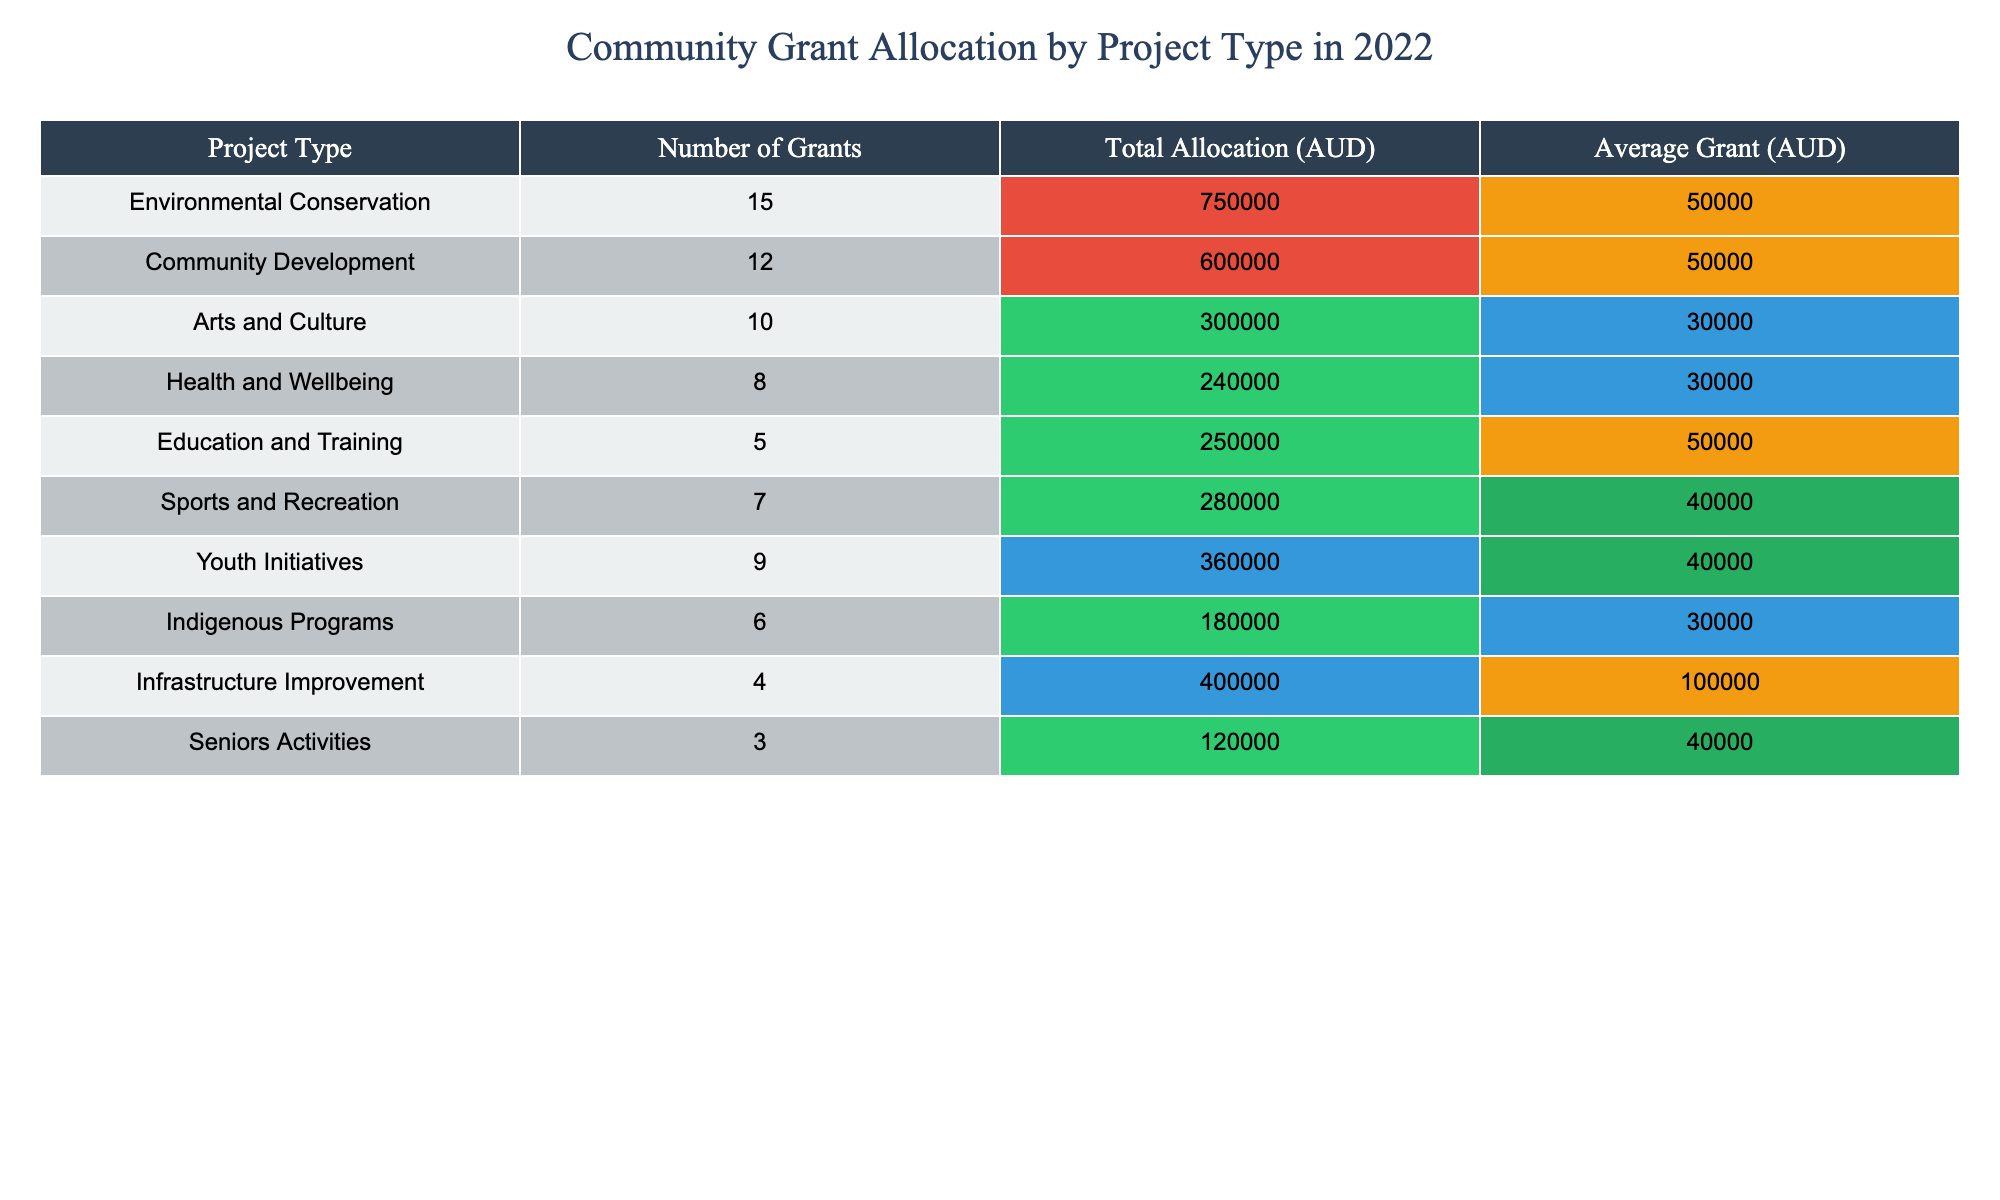What project type received the highest total allocation in 2022? The project type with the highest total allocation can be found by looking for the maximum value in the "Total Allocation (AUD)" column. The highest value is 750000, which corresponds to "Environmental Conservation."
Answer: Environmental Conservation How many grants were awarded for Community Development? The number of grants for "Community Development" is directly listed in the table under the "Number of Grants" column. It is 12.
Answer: 12 What is the average grant amount for Sports and Recreation? The average grant amount for "Sports and Recreation" can be found in the "Average Grant (AUD)" column. It is 40000.
Answer: 40000 Which project type had the fewest number of grants awarded? To determine which project had the fewest grants, we compare the values in the "Number of Grants" column. The minimum value is 3, associated with "Seniors Activities."
Answer: Seniors Activities What is the total allocation for Youth Initiatives and Health and Wellbeing combined? The total allocation for "Youth Initiatives" is 360000 and for "Health and Wellbeing" is 240000. Adding these gives 360000 + 240000 = 600000.
Answer: 600000 Is the average grant amount for Education and Training greater than that for Arts and Culture? The average grant for "Education and Training" is 50000 and for "Arts and Culture" it is 30000. Since 50000 is greater than 30000, the statement is true.
Answer: Yes What is the total allocation for all projects with an average grant of at least 40000? The project types with an average grant of at least 40000 are "Environmental Conservation," "Community Development," "Sports and Recreation," and "Youth Initiatives." Their allocations are 750000, 600000, 280000, and 360000 respectively. Adding these gives 750000 + 600000 + 280000 + 360000 = 1990000.
Answer: 1990000 How many more projects received grants in the Environmental Conservation category compared to Indigenous Programs? "Environmental Conservation" had 15 grants and "Indigenous Programs" had 6 grants. The difference is 15 - 6 = 9.
Answer: 9 How many project types received more than 400000 AUD in total allocation? The project types with more than 400000 AUD in total allocation are "Environmental Conservation" (750000), "Community Development" (600000), and "Infrastructure Improvement" (400000). This gives three project types.
Answer: 3 What percentage of the total allocation was given to Arts and Culture? The total allocation across all projects can be calculated by summing the "Total Allocation (AUD)" column. The allocation for "Arts and Culture" is 300000. The total allocation is 750000 + 600000 + 300000 + 240000 + 250000 + 280000 + 360000 + 180000 + 400000 + 120000 = 2880000. The percentage is (300000 / 2880000) * 100 = 10.42%.
Answer: 10.42% 